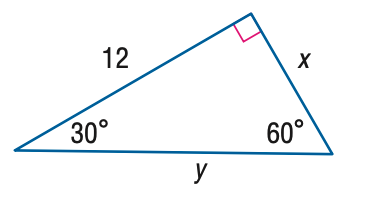Question: Find y.
Choices:
A. 8 \sqrt { 3 }
B. 12 \sqrt { 3 }
C. 24
D. 16 \sqrt { 3 }
Answer with the letter. Answer: A Question: Find x.
Choices:
A. 4
B. 6
C. 4 \sqrt { 3 }
D. 8 \sqrt { 3 }
Answer with the letter. Answer: C 